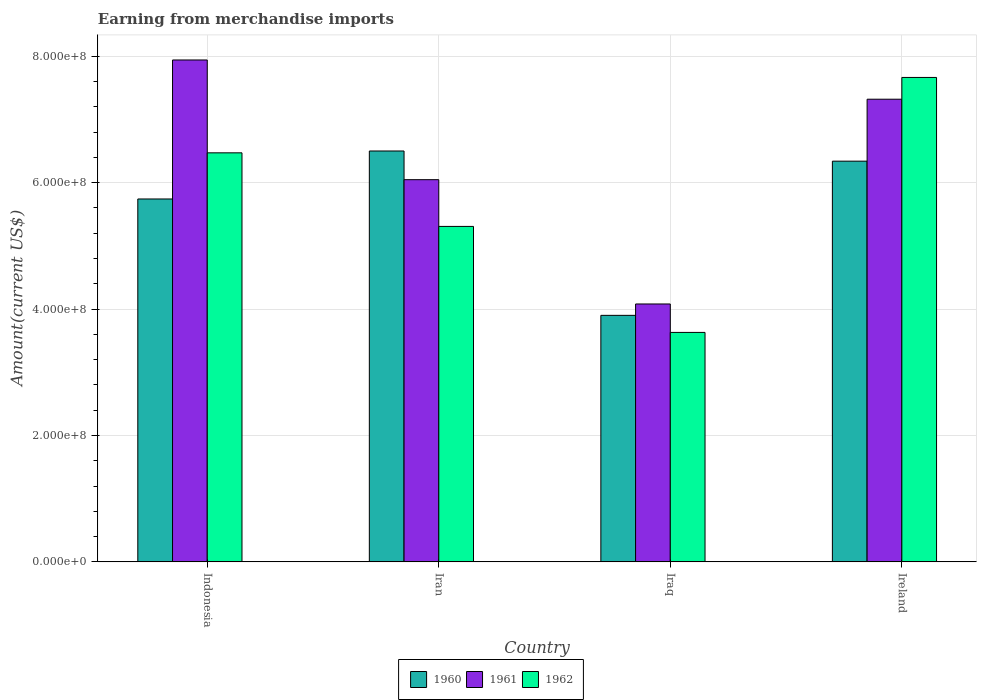How many different coloured bars are there?
Give a very brief answer. 3. Are the number of bars per tick equal to the number of legend labels?
Make the answer very short. Yes. Are the number of bars on each tick of the X-axis equal?
Give a very brief answer. Yes. What is the label of the 3rd group of bars from the left?
Your response must be concise. Iraq. What is the amount earned from merchandise imports in 1960 in Iran?
Provide a succinct answer. 6.50e+08. Across all countries, what is the maximum amount earned from merchandise imports in 1962?
Your answer should be compact. 7.66e+08. Across all countries, what is the minimum amount earned from merchandise imports in 1962?
Your answer should be compact. 3.63e+08. In which country was the amount earned from merchandise imports in 1960 maximum?
Make the answer very short. Iran. In which country was the amount earned from merchandise imports in 1961 minimum?
Offer a very short reply. Iraq. What is the total amount earned from merchandise imports in 1960 in the graph?
Offer a terse response. 2.25e+09. What is the difference between the amount earned from merchandise imports in 1960 in Indonesia and that in Ireland?
Provide a succinct answer. -5.98e+07. What is the difference between the amount earned from merchandise imports in 1960 in Ireland and the amount earned from merchandise imports in 1961 in Iran?
Offer a very short reply. 2.93e+07. What is the average amount earned from merchandise imports in 1960 per country?
Your answer should be compact. 5.62e+08. What is the difference between the amount earned from merchandise imports of/in 1961 and amount earned from merchandise imports of/in 1960 in Iraq?
Offer a terse response. 1.80e+07. In how many countries, is the amount earned from merchandise imports in 1960 greater than 760000000 US$?
Offer a terse response. 0. What is the ratio of the amount earned from merchandise imports in 1960 in Iran to that in Ireland?
Your answer should be very brief. 1.03. Is the amount earned from merchandise imports in 1960 in Iran less than that in Ireland?
Your answer should be very brief. No. What is the difference between the highest and the second highest amount earned from merchandise imports in 1960?
Provide a short and direct response. 1.61e+07. What is the difference between the highest and the lowest amount earned from merchandise imports in 1961?
Offer a very short reply. 3.86e+08. What does the 1st bar from the left in Iran represents?
Provide a succinct answer. 1960. Are all the bars in the graph horizontal?
Your answer should be compact. No. Does the graph contain grids?
Keep it short and to the point. Yes. Where does the legend appear in the graph?
Your answer should be very brief. Bottom center. What is the title of the graph?
Make the answer very short. Earning from merchandise imports. Does "1960" appear as one of the legend labels in the graph?
Your answer should be compact. Yes. What is the label or title of the X-axis?
Make the answer very short. Country. What is the label or title of the Y-axis?
Your response must be concise. Amount(current US$). What is the Amount(current US$) of 1960 in Indonesia?
Make the answer very short. 5.74e+08. What is the Amount(current US$) in 1961 in Indonesia?
Give a very brief answer. 7.94e+08. What is the Amount(current US$) of 1962 in Indonesia?
Ensure brevity in your answer.  6.47e+08. What is the Amount(current US$) of 1960 in Iran?
Your response must be concise. 6.50e+08. What is the Amount(current US$) in 1961 in Iran?
Your answer should be very brief. 6.05e+08. What is the Amount(current US$) in 1962 in Iran?
Make the answer very short. 5.31e+08. What is the Amount(current US$) in 1960 in Iraq?
Keep it short and to the point. 3.90e+08. What is the Amount(current US$) in 1961 in Iraq?
Provide a short and direct response. 4.08e+08. What is the Amount(current US$) of 1962 in Iraq?
Give a very brief answer. 3.63e+08. What is the Amount(current US$) of 1960 in Ireland?
Provide a short and direct response. 6.34e+08. What is the Amount(current US$) in 1961 in Ireland?
Ensure brevity in your answer.  7.32e+08. What is the Amount(current US$) in 1962 in Ireland?
Your response must be concise. 7.66e+08. Across all countries, what is the maximum Amount(current US$) of 1960?
Ensure brevity in your answer.  6.50e+08. Across all countries, what is the maximum Amount(current US$) of 1961?
Make the answer very short. 7.94e+08. Across all countries, what is the maximum Amount(current US$) of 1962?
Keep it short and to the point. 7.66e+08. Across all countries, what is the minimum Amount(current US$) in 1960?
Provide a short and direct response. 3.90e+08. Across all countries, what is the minimum Amount(current US$) in 1961?
Make the answer very short. 4.08e+08. Across all countries, what is the minimum Amount(current US$) in 1962?
Provide a succinct answer. 3.63e+08. What is the total Amount(current US$) in 1960 in the graph?
Your response must be concise. 2.25e+09. What is the total Amount(current US$) of 1961 in the graph?
Make the answer very short. 2.54e+09. What is the total Amount(current US$) in 1962 in the graph?
Keep it short and to the point. 2.31e+09. What is the difference between the Amount(current US$) of 1960 in Indonesia and that in Iran?
Provide a succinct answer. -7.59e+07. What is the difference between the Amount(current US$) of 1961 in Indonesia and that in Iran?
Give a very brief answer. 1.89e+08. What is the difference between the Amount(current US$) of 1962 in Indonesia and that in Iran?
Give a very brief answer. 1.16e+08. What is the difference between the Amount(current US$) in 1960 in Indonesia and that in Iraq?
Your answer should be compact. 1.84e+08. What is the difference between the Amount(current US$) of 1961 in Indonesia and that in Iraq?
Ensure brevity in your answer.  3.86e+08. What is the difference between the Amount(current US$) of 1962 in Indonesia and that in Iraq?
Offer a very short reply. 2.84e+08. What is the difference between the Amount(current US$) of 1960 in Indonesia and that in Ireland?
Your answer should be compact. -5.98e+07. What is the difference between the Amount(current US$) in 1961 in Indonesia and that in Ireland?
Provide a succinct answer. 6.21e+07. What is the difference between the Amount(current US$) in 1962 in Indonesia and that in Ireland?
Keep it short and to the point. -1.19e+08. What is the difference between the Amount(current US$) of 1960 in Iran and that in Iraq?
Provide a short and direct response. 2.60e+08. What is the difference between the Amount(current US$) in 1961 in Iran and that in Iraq?
Offer a very short reply. 1.97e+08. What is the difference between the Amount(current US$) in 1962 in Iran and that in Iraq?
Offer a terse response. 1.68e+08. What is the difference between the Amount(current US$) of 1960 in Iran and that in Ireland?
Keep it short and to the point. 1.61e+07. What is the difference between the Amount(current US$) in 1961 in Iran and that in Ireland?
Provide a short and direct response. -1.27e+08. What is the difference between the Amount(current US$) of 1962 in Iran and that in Ireland?
Your answer should be compact. -2.36e+08. What is the difference between the Amount(current US$) of 1960 in Iraq and that in Ireland?
Give a very brief answer. -2.44e+08. What is the difference between the Amount(current US$) of 1961 in Iraq and that in Ireland?
Keep it short and to the point. -3.24e+08. What is the difference between the Amount(current US$) of 1962 in Iraq and that in Ireland?
Provide a succinct answer. -4.03e+08. What is the difference between the Amount(current US$) in 1960 in Indonesia and the Amount(current US$) in 1961 in Iran?
Provide a short and direct response. -3.05e+07. What is the difference between the Amount(current US$) of 1960 in Indonesia and the Amount(current US$) of 1962 in Iran?
Make the answer very short. 4.34e+07. What is the difference between the Amount(current US$) in 1961 in Indonesia and the Amount(current US$) in 1962 in Iran?
Ensure brevity in your answer.  2.63e+08. What is the difference between the Amount(current US$) in 1960 in Indonesia and the Amount(current US$) in 1961 in Iraq?
Ensure brevity in your answer.  1.66e+08. What is the difference between the Amount(current US$) of 1960 in Indonesia and the Amount(current US$) of 1962 in Iraq?
Your answer should be compact. 2.11e+08. What is the difference between the Amount(current US$) in 1961 in Indonesia and the Amount(current US$) in 1962 in Iraq?
Provide a short and direct response. 4.31e+08. What is the difference between the Amount(current US$) of 1960 in Indonesia and the Amount(current US$) of 1961 in Ireland?
Your answer should be very brief. -1.58e+08. What is the difference between the Amount(current US$) in 1960 in Indonesia and the Amount(current US$) in 1962 in Ireland?
Keep it short and to the point. -1.92e+08. What is the difference between the Amount(current US$) of 1961 in Indonesia and the Amount(current US$) of 1962 in Ireland?
Provide a short and direct response. 2.76e+07. What is the difference between the Amount(current US$) of 1960 in Iran and the Amount(current US$) of 1961 in Iraq?
Give a very brief answer. 2.42e+08. What is the difference between the Amount(current US$) of 1960 in Iran and the Amount(current US$) of 1962 in Iraq?
Offer a very short reply. 2.87e+08. What is the difference between the Amount(current US$) in 1961 in Iran and the Amount(current US$) in 1962 in Iraq?
Your response must be concise. 2.42e+08. What is the difference between the Amount(current US$) in 1960 in Iran and the Amount(current US$) in 1961 in Ireland?
Give a very brief answer. -8.19e+07. What is the difference between the Amount(current US$) in 1960 in Iran and the Amount(current US$) in 1962 in Ireland?
Offer a terse response. -1.16e+08. What is the difference between the Amount(current US$) in 1961 in Iran and the Amount(current US$) in 1962 in Ireland?
Your answer should be very brief. -1.62e+08. What is the difference between the Amount(current US$) of 1960 in Iraq and the Amount(current US$) of 1961 in Ireland?
Provide a short and direct response. -3.42e+08. What is the difference between the Amount(current US$) of 1960 in Iraq and the Amount(current US$) of 1962 in Ireland?
Give a very brief answer. -3.76e+08. What is the difference between the Amount(current US$) of 1961 in Iraq and the Amount(current US$) of 1962 in Ireland?
Your answer should be compact. -3.58e+08. What is the average Amount(current US$) of 1960 per country?
Ensure brevity in your answer.  5.62e+08. What is the average Amount(current US$) of 1961 per country?
Your response must be concise. 6.35e+08. What is the average Amount(current US$) in 1962 per country?
Your answer should be compact. 5.77e+08. What is the difference between the Amount(current US$) of 1960 and Amount(current US$) of 1961 in Indonesia?
Your response must be concise. -2.20e+08. What is the difference between the Amount(current US$) in 1960 and Amount(current US$) in 1962 in Indonesia?
Provide a short and direct response. -7.30e+07. What is the difference between the Amount(current US$) of 1961 and Amount(current US$) of 1962 in Indonesia?
Your answer should be compact. 1.47e+08. What is the difference between the Amount(current US$) of 1960 and Amount(current US$) of 1961 in Iran?
Give a very brief answer. 4.54e+07. What is the difference between the Amount(current US$) in 1960 and Amount(current US$) in 1962 in Iran?
Your answer should be compact. 1.19e+08. What is the difference between the Amount(current US$) in 1961 and Amount(current US$) in 1962 in Iran?
Ensure brevity in your answer.  7.39e+07. What is the difference between the Amount(current US$) of 1960 and Amount(current US$) of 1961 in Iraq?
Make the answer very short. -1.80e+07. What is the difference between the Amount(current US$) of 1960 and Amount(current US$) of 1962 in Iraq?
Offer a very short reply. 2.70e+07. What is the difference between the Amount(current US$) of 1961 and Amount(current US$) of 1962 in Iraq?
Provide a succinct answer. 4.50e+07. What is the difference between the Amount(current US$) of 1960 and Amount(current US$) of 1961 in Ireland?
Your response must be concise. -9.80e+07. What is the difference between the Amount(current US$) of 1960 and Amount(current US$) of 1962 in Ireland?
Provide a short and direct response. -1.32e+08. What is the difference between the Amount(current US$) in 1961 and Amount(current US$) in 1962 in Ireland?
Make the answer very short. -3.44e+07. What is the ratio of the Amount(current US$) in 1960 in Indonesia to that in Iran?
Give a very brief answer. 0.88. What is the ratio of the Amount(current US$) in 1961 in Indonesia to that in Iran?
Make the answer very short. 1.31. What is the ratio of the Amount(current US$) in 1962 in Indonesia to that in Iran?
Provide a succinct answer. 1.22. What is the ratio of the Amount(current US$) in 1960 in Indonesia to that in Iraq?
Offer a very short reply. 1.47. What is the ratio of the Amount(current US$) of 1961 in Indonesia to that in Iraq?
Your response must be concise. 1.95. What is the ratio of the Amount(current US$) of 1962 in Indonesia to that in Iraq?
Provide a succinct answer. 1.78. What is the ratio of the Amount(current US$) in 1960 in Indonesia to that in Ireland?
Your answer should be very brief. 0.91. What is the ratio of the Amount(current US$) of 1961 in Indonesia to that in Ireland?
Your answer should be compact. 1.08. What is the ratio of the Amount(current US$) of 1962 in Indonesia to that in Ireland?
Your response must be concise. 0.84. What is the ratio of the Amount(current US$) of 1960 in Iran to that in Iraq?
Provide a short and direct response. 1.67. What is the ratio of the Amount(current US$) of 1961 in Iran to that in Iraq?
Provide a short and direct response. 1.48. What is the ratio of the Amount(current US$) in 1962 in Iran to that in Iraq?
Provide a short and direct response. 1.46. What is the ratio of the Amount(current US$) of 1960 in Iran to that in Ireland?
Offer a very short reply. 1.03. What is the ratio of the Amount(current US$) in 1961 in Iran to that in Ireland?
Your answer should be very brief. 0.83. What is the ratio of the Amount(current US$) in 1962 in Iran to that in Ireland?
Keep it short and to the point. 0.69. What is the ratio of the Amount(current US$) in 1960 in Iraq to that in Ireland?
Your answer should be very brief. 0.62. What is the ratio of the Amount(current US$) of 1961 in Iraq to that in Ireland?
Give a very brief answer. 0.56. What is the ratio of the Amount(current US$) of 1962 in Iraq to that in Ireland?
Keep it short and to the point. 0.47. What is the difference between the highest and the second highest Amount(current US$) in 1960?
Make the answer very short. 1.61e+07. What is the difference between the highest and the second highest Amount(current US$) of 1961?
Offer a terse response. 6.21e+07. What is the difference between the highest and the second highest Amount(current US$) of 1962?
Give a very brief answer. 1.19e+08. What is the difference between the highest and the lowest Amount(current US$) of 1960?
Ensure brevity in your answer.  2.60e+08. What is the difference between the highest and the lowest Amount(current US$) in 1961?
Your answer should be compact. 3.86e+08. What is the difference between the highest and the lowest Amount(current US$) in 1962?
Keep it short and to the point. 4.03e+08. 